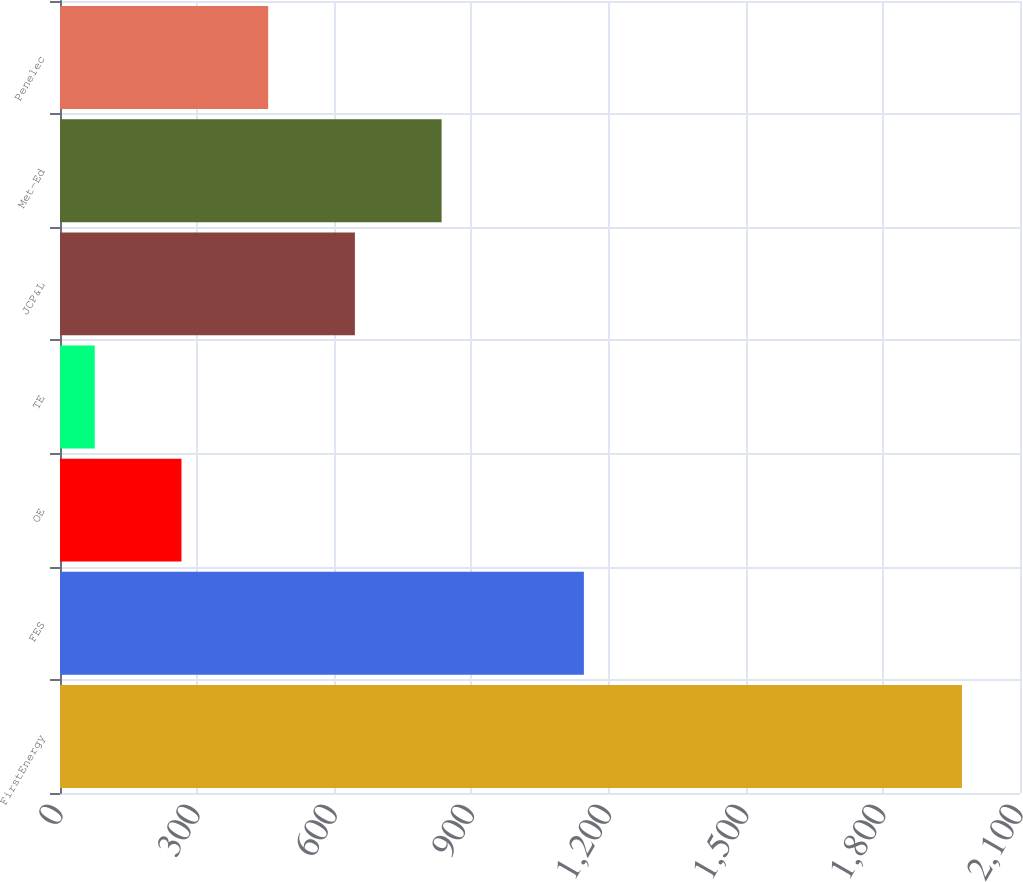<chart> <loc_0><loc_0><loc_500><loc_500><bar_chart><fcel>FirstEnergy<fcel>FES<fcel>OE<fcel>TE<fcel>JCP&L<fcel>Met-Ed<fcel>Penelec<nl><fcel>1973<fcel>1146<fcel>265.7<fcel>76<fcel>645.1<fcel>834.8<fcel>455.4<nl></chart> 